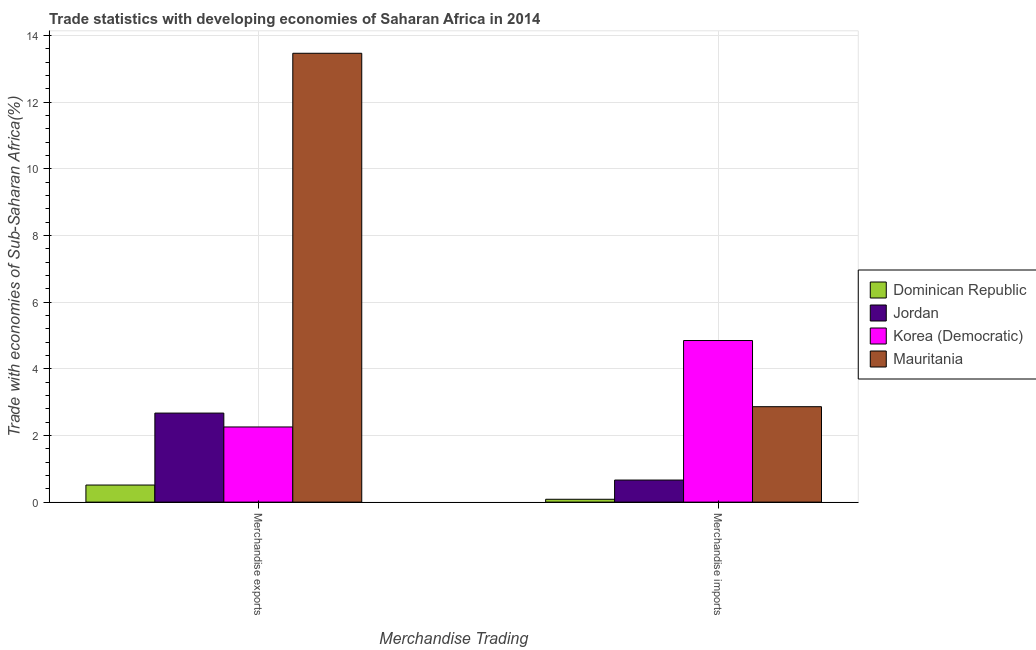How many different coloured bars are there?
Your answer should be compact. 4. How many groups of bars are there?
Your answer should be very brief. 2. Are the number of bars per tick equal to the number of legend labels?
Ensure brevity in your answer.  Yes. How many bars are there on the 1st tick from the left?
Your answer should be compact. 4. What is the merchandise exports in Korea (Democratic)?
Provide a succinct answer. 2.25. Across all countries, what is the maximum merchandise imports?
Make the answer very short. 4.85. Across all countries, what is the minimum merchandise exports?
Provide a short and direct response. 0.51. In which country was the merchandise exports maximum?
Your answer should be compact. Mauritania. In which country was the merchandise exports minimum?
Give a very brief answer. Dominican Republic. What is the total merchandise imports in the graph?
Your answer should be compact. 8.46. What is the difference between the merchandise imports in Mauritania and that in Dominican Republic?
Your response must be concise. 2.78. What is the difference between the merchandise exports in Jordan and the merchandise imports in Dominican Republic?
Provide a succinct answer. 2.59. What is the average merchandise exports per country?
Keep it short and to the point. 4.73. What is the difference between the merchandise imports and merchandise exports in Dominican Republic?
Your answer should be very brief. -0.43. What is the ratio of the merchandise imports in Mauritania to that in Dominican Republic?
Your answer should be compact. 33.54. What does the 4th bar from the left in Merchandise imports represents?
Keep it short and to the point. Mauritania. What does the 3rd bar from the right in Merchandise imports represents?
Offer a terse response. Jordan. How many bars are there?
Offer a terse response. 8. How many countries are there in the graph?
Keep it short and to the point. 4. What is the difference between two consecutive major ticks on the Y-axis?
Ensure brevity in your answer.  2. Are the values on the major ticks of Y-axis written in scientific E-notation?
Offer a very short reply. No. Does the graph contain grids?
Ensure brevity in your answer.  Yes. What is the title of the graph?
Offer a very short reply. Trade statistics with developing economies of Saharan Africa in 2014. Does "Portugal" appear as one of the legend labels in the graph?
Keep it short and to the point. No. What is the label or title of the X-axis?
Keep it short and to the point. Merchandise Trading. What is the label or title of the Y-axis?
Provide a short and direct response. Trade with economies of Sub-Saharan Africa(%). What is the Trade with economies of Sub-Saharan Africa(%) of Dominican Republic in Merchandise exports?
Offer a terse response. 0.51. What is the Trade with economies of Sub-Saharan Africa(%) in Jordan in Merchandise exports?
Offer a very short reply. 2.67. What is the Trade with economies of Sub-Saharan Africa(%) of Korea (Democratic) in Merchandise exports?
Provide a short and direct response. 2.25. What is the Trade with economies of Sub-Saharan Africa(%) of Mauritania in Merchandise exports?
Make the answer very short. 13.46. What is the Trade with economies of Sub-Saharan Africa(%) of Dominican Republic in Merchandise imports?
Make the answer very short. 0.09. What is the Trade with economies of Sub-Saharan Africa(%) of Jordan in Merchandise imports?
Keep it short and to the point. 0.66. What is the Trade with economies of Sub-Saharan Africa(%) of Korea (Democratic) in Merchandise imports?
Give a very brief answer. 4.85. What is the Trade with economies of Sub-Saharan Africa(%) in Mauritania in Merchandise imports?
Ensure brevity in your answer.  2.86. Across all Merchandise Trading, what is the maximum Trade with economies of Sub-Saharan Africa(%) in Dominican Republic?
Provide a succinct answer. 0.51. Across all Merchandise Trading, what is the maximum Trade with economies of Sub-Saharan Africa(%) of Jordan?
Offer a very short reply. 2.67. Across all Merchandise Trading, what is the maximum Trade with economies of Sub-Saharan Africa(%) in Korea (Democratic)?
Provide a succinct answer. 4.85. Across all Merchandise Trading, what is the maximum Trade with economies of Sub-Saharan Africa(%) of Mauritania?
Ensure brevity in your answer.  13.46. Across all Merchandise Trading, what is the minimum Trade with economies of Sub-Saharan Africa(%) of Dominican Republic?
Offer a terse response. 0.09. Across all Merchandise Trading, what is the minimum Trade with economies of Sub-Saharan Africa(%) of Jordan?
Keep it short and to the point. 0.66. Across all Merchandise Trading, what is the minimum Trade with economies of Sub-Saharan Africa(%) in Korea (Democratic)?
Make the answer very short. 2.25. Across all Merchandise Trading, what is the minimum Trade with economies of Sub-Saharan Africa(%) of Mauritania?
Your answer should be very brief. 2.86. What is the total Trade with economies of Sub-Saharan Africa(%) of Dominican Republic in the graph?
Offer a very short reply. 0.6. What is the total Trade with economies of Sub-Saharan Africa(%) in Jordan in the graph?
Your answer should be very brief. 3.33. What is the total Trade with economies of Sub-Saharan Africa(%) in Korea (Democratic) in the graph?
Offer a terse response. 7.1. What is the total Trade with economies of Sub-Saharan Africa(%) in Mauritania in the graph?
Provide a short and direct response. 16.32. What is the difference between the Trade with economies of Sub-Saharan Africa(%) in Dominican Republic in Merchandise exports and that in Merchandise imports?
Offer a very short reply. 0.43. What is the difference between the Trade with economies of Sub-Saharan Africa(%) of Jordan in Merchandise exports and that in Merchandise imports?
Provide a succinct answer. 2.01. What is the difference between the Trade with economies of Sub-Saharan Africa(%) in Korea (Democratic) in Merchandise exports and that in Merchandise imports?
Your answer should be very brief. -2.59. What is the difference between the Trade with economies of Sub-Saharan Africa(%) of Mauritania in Merchandise exports and that in Merchandise imports?
Your answer should be compact. 10.6. What is the difference between the Trade with economies of Sub-Saharan Africa(%) in Dominican Republic in Merchandise exports and the Trade with economies of Sub-Saharan Africa(%) in Jordan in Merchandise imports?
Keep it short and to the point. -0.15. What is the difference between the Trade with economies of Sub-Saharan Africa(%) of Dominican Republic in Merchandise exports and the Trade with economies of Sub-Saharan Africa(%) of Korea (Democratic) in Merchandise imports?
Offer a terse response. -4.33. What is the difference between the Trade with economies of Sub-Saharan Africa(%) of Dominican Republic in Merchandise exports and the Trade with economies of Sub-Saharan Africa(%) of Mauritania in Merchandise imports?
Your answer should be very brief. -2.35. What is the difference between the Trade with economies of Sub-Saharan Africa(%) of Jordan in Merchandise exports and the Trade with economies of Sub-Saharan Africa(%) of Korea (Democratic) in Merchandise imports?
Ensure brevity in your answer.  -2.18. What is the difference between the Trade with economies of Sub-Saharan Africa(%) in Jordan in Merchandise exports and the Trade with economies of Sub-Saharan Africa(%) in Mauritania in Merchandise imports?
Your answer should be very brief. -0.19. What is the difference between the Trade with economies of Sub-Saharan Africa(%) of Korea (Democratic) in Merchandise exports and the Trade with economies of Sub-Saharan Africa(%) of Mauritania in Merchandise imports?
Your answer should be compact. -0.61. What is the average Trade with economies of Sub-Saharan Africa(%) of Dominican Republic per Merchandise Trading?
Your response must be concise. 0.3. What is the average Trade with economies of Sub-Saharan Africa(%) in Jordan per Merchandise Trading?
Provide a short and direct response. 1.67. What is the average Trade with economies of Sub-Saharan Africa(%) in Korea (Democratic) per Merchandise Trading?
Keep it short and to the point. 3.55. What is the average Trade with economies of Sub-Saharan Africa(%) of Mauritania per Merchandise Trading?
Your response must be concise. 8.16. What is the difference between the Trade with economies of Sub-Saharan Africa(%) in Dominican Republic and Trade with economies of Sub-Saharan Africa(%) in Jordan in Merchandise exports?
Your answer should be compact. -2.16. What is the difference between the Trade with economies of Sub-Saharan Africa(%) in Dominican Republic and Trade with economies of Sub-Saharan Africa(%) in Korea (Democratic) in Merchandise exports?
Provide a short and direct response. -1.74. What is the difference between the Trade with economies of Sub-Saharan Africa(%) of Dominican Republic and Trade with economies of Sub-Saharan Africa(%) of Mauritania in Merchandise exports?
Offer a very short reply. -12.95. What is the difference between the Trade with economies of Sub-Saharan Africa(%) in Jordan and Trade with economies of Sub-Saharan Africa(%) in Korea (Democratic) in Merchandise exports?
Your answer should be compact. 0.42. What is the difference between the Trade with economies of Sub-Saharan Africa(%) in Jordan and Trade with economies of Sub-Saharan Africa(%) in Mauritania in Merchandise exports?
Provide a short and direct response. -10.79. What is the difference between the Trade with economies of Sub-Saharan Africa(%) of Korea (Democratic) and Trade with economies of Sub-Saharan Africa(%) of Mauritania in Merchandise exports?
Make the answer very short. -11.21. What is the difference between the Trade with economies of Sub-Saharan Africa(%) of Dominican Republic and Trade with economies of Sub-Saharan Africa(%) of Jordan in Merchandise imports?
Offer a very short reply. -0.58. What is the difference between the Trade with economies of Sub-Saharan Africa(%) in Dominican Republic and Trade with economies of Sub-Saharan Africa(%) in Korea (Democratic) in Merchandise imports?
Offer a very short reply. -4.76. What is the difference between the Trade with economies of Sub-Saharan Africa(%) in Dominican Republic and Trade with economies of Sub-Saharan Africa(%) in Mauritania in Merchandise imports?
Give a very brief answer. -2.78. What is the difference between the Trade with economies of Sub-Saharan Africa(%) in Jordan and Trade with economies of Sub-Saharan Africa(%) in Korea (Democratic) in Merchandise imports?
Keep it short and to the point. -4.19. What is the difference between the Trade with economies of Sub-Saharan Africa(%) in Jordan and Trade with economies of Sub-Saharan Africa(%) in Mauritania in Merchandise imports?
Your answer should be very brief. -2.2. What is the difference between the Trade with economies of Sub-Saharan Africa(%) in Korea (Democratic) and Trade with economies of Sub-Saharan Africa(%) in Mauritania in Merchandise imports?
Offer a very short reply. 1.99. What is the ratio of the Trade with economies of Sub-Saharan Africa(%) of Dominican Republic in Merchandise exports to that in Merchandise imports?
Your response must be concise. 6.01. What is the ratio of the Trade with economies of Sub-Saharan Africa(%) of Jordan in Merchandise exports to that in Merchandise imports?
Keep it short and to the point. 4.03. What is the ratio of the Trade with economies of Sub-Saharan Africa(%) in Korea (Democratic) in Merchandise exports to that in Merchandise imports?
Your answer should be very brief. 0.47. What is the ratio of the Trade with economies of Sub-Saharan Africa(%) of Mauritania in Merchandise exports to that in Merchandise imports?
Keep it short and to the point. 4.7. What is the difference between the highest and the second highest Trade with economies of Sub-Saharan Africa(%) in Dominican Republic?
Your answer should be very brief. 0.43. What is the difference between the highest and the second highest Trade with economies of Sub-Saharan Africa(%) of Jordan?
Ensure brevity in your answer.  2.01. What is the difference between the highest and the second highest Trade with economies of Sub-Saharan Africa(%) of Korea (Democratic)?
Offer a terse response. 2.59. What is the difference between the highest and the second highest Trade with economies of Sub-Saharan Africa(%) in Mauritania?
Your answer should be compact. 10.6. What is the difference between the highest and the lowest Trade with economies of Sub-Saharan Africa(%) in Dominican Republic?
Offer a very short reply. 0.43. What is the difference between the highest and the lowest Trade with economies of Sub-Saharan Africa(%) in Jordan?
Your response must be concise. 2.01. What is the difference between the highest and the lowest Trade with economies of Sub-Saharan Africa(%) of Korea (Democratic)?
Give a very brief answer. 2.59. What is the difference between the highest and the lowest Trade with economies of Sub-Saharan Africa(%) in Mauritania?
Provide a short and direct response. 10.6. 